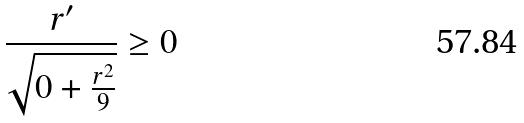Convert formula to latex. <formula><loc_0><loc_0><loc_500><loc_500>\frac { r ^ { \prime } } { \sqrt { 0 + \frac { r ^ { 2 } } { 9 } } } \geq 0</formula> 